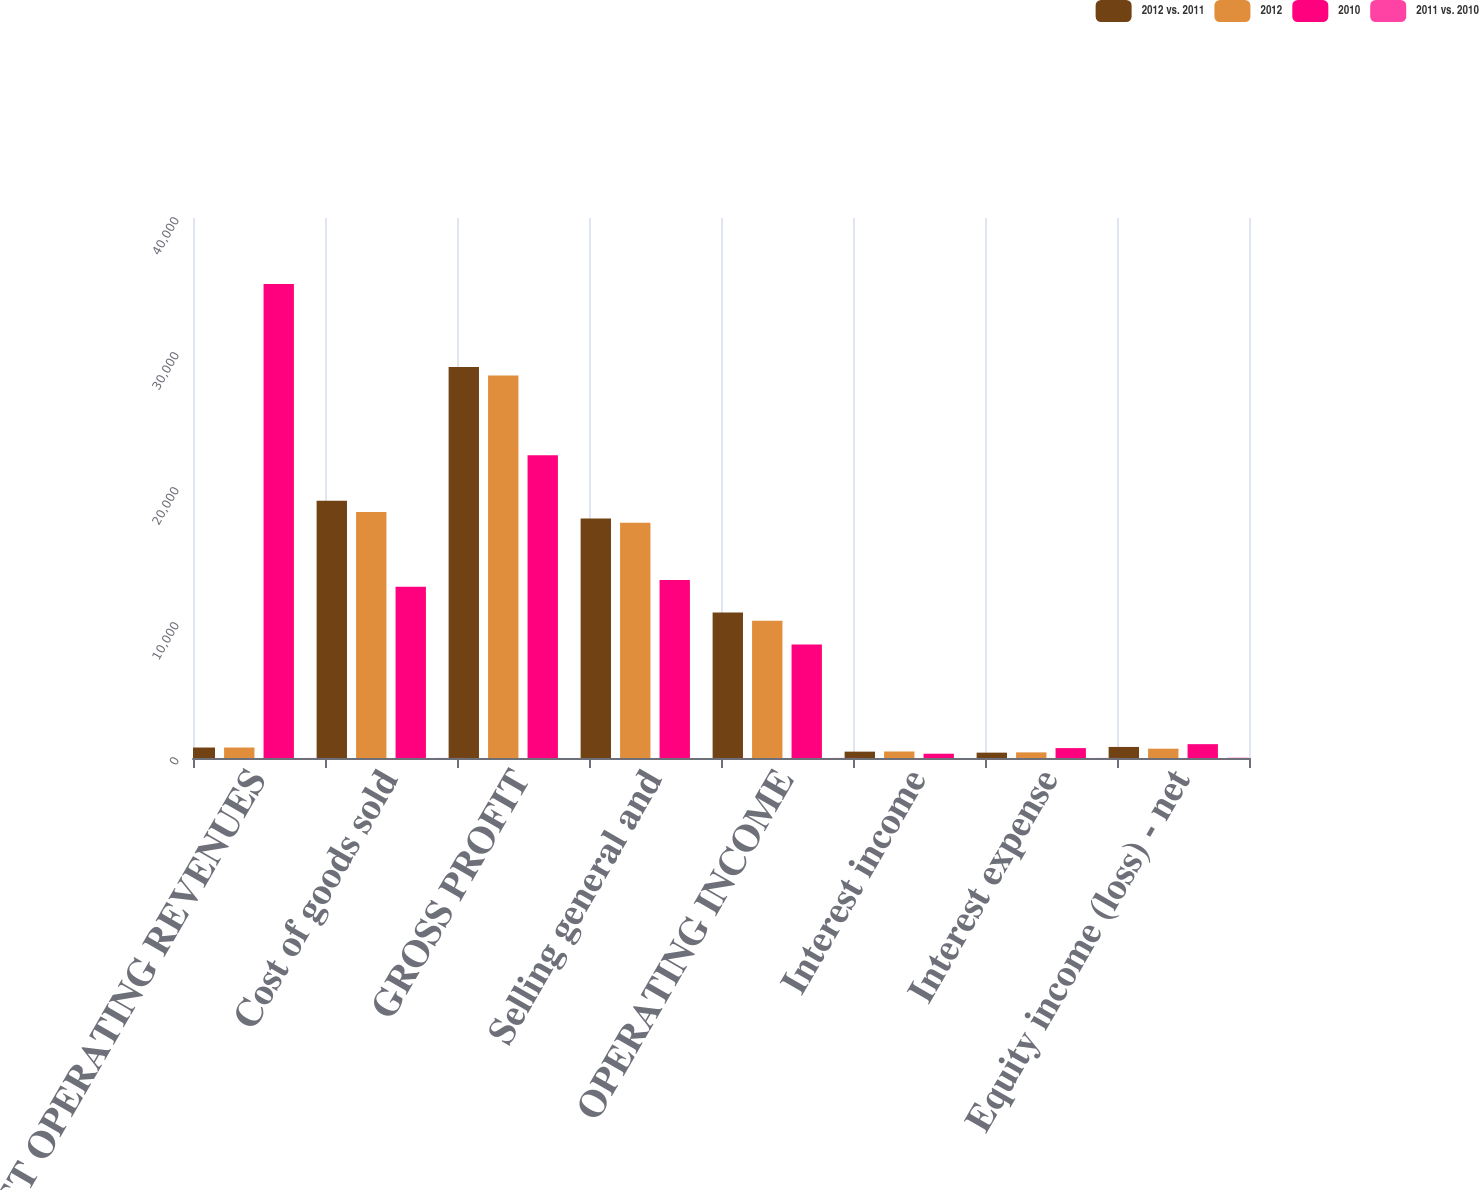Convert chart. <chart><loc_0><loc_0><loc_500><loc_500><stacked_bar_chart><ecel><fcel>NET OPERATING REVENUES<fcel>Cost of goods sold<fcel>GROSS PROFIT<fcel>Selling general and<fcel>OPERATING INCOME<fcel>Interest income<fcel>Interest expense<fcel>Equity income (loss) - net<nl><fcel>2012 vs. 2011<fcel>776<fcel>19053<fcel>28964<fcel>17738<fcel>10779<fcel>471<fcel>397<fcel>819<nl><fcel>2012<fcel>776<fcel>18215<fcel>28327<fcel>17422<fcel>10173<fcel>483<fcel>417<fcel>690<nl><fcel>2010<fcel>35119<fcel>12693<fcel>22426<fcel>13194<fcel>8413<fcel>317<fcel>733<fcel>1025<nl><fcel>2011 vs. 2010<fcel>3<fcel>5<fcel>2<fcel>2<fcel>6<fcel>2<fcel>5<fcel>19<nl></chart> 